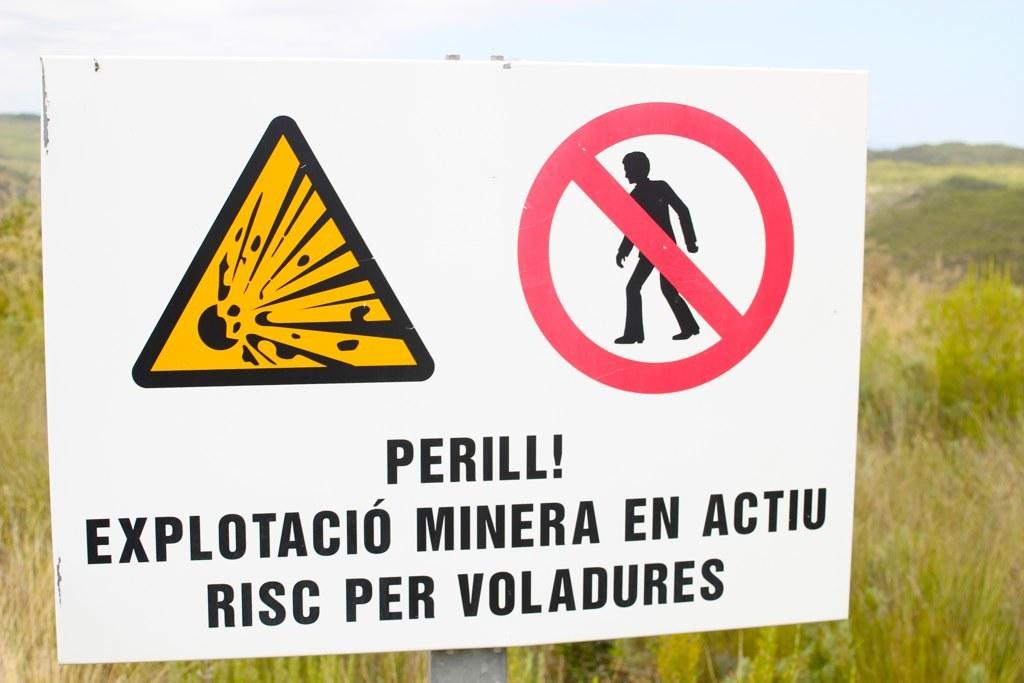<image>
Share a concise interpretation of the image provided. A warning sign in a field says "Perill! Explotacio Minera En Actiu Risc Per Voladures" 